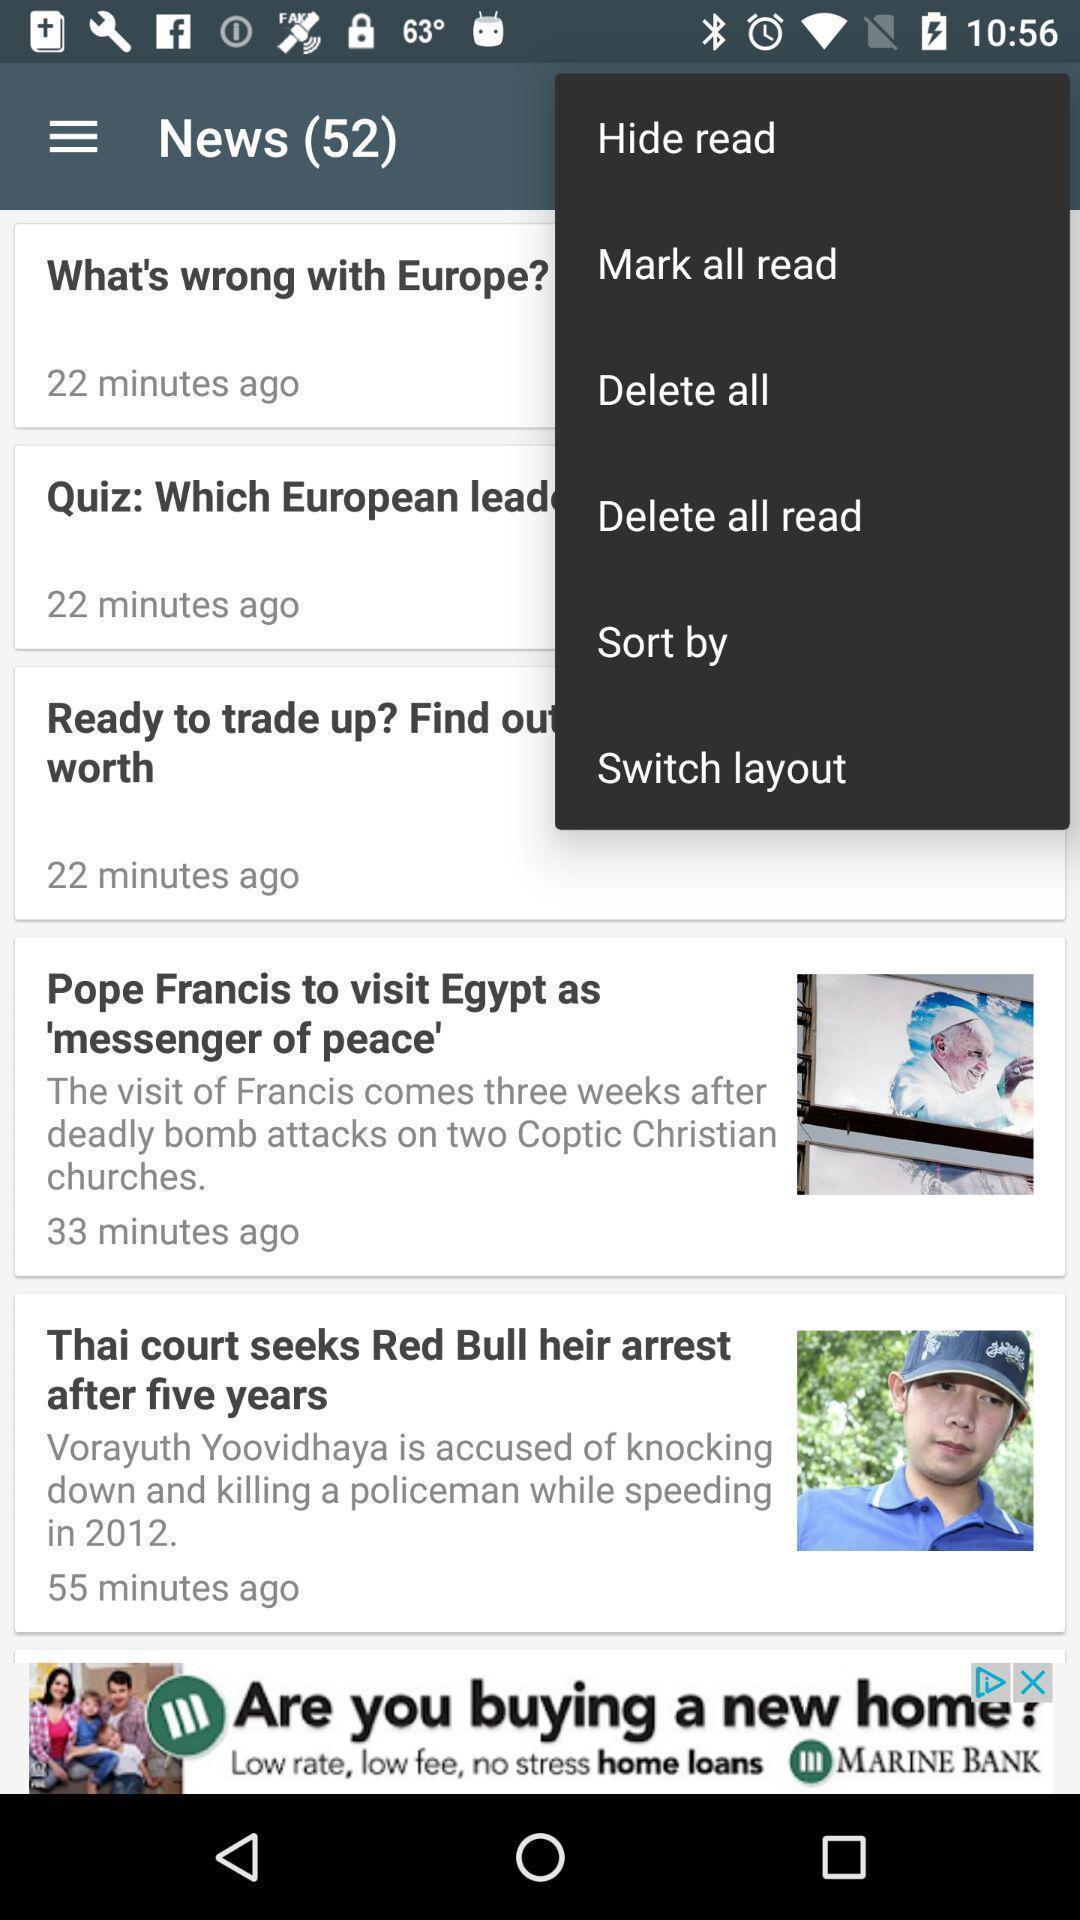Provide a textual representation of this image. Pop up the new in a new app. 